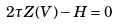<formula> <loc_0><loc_0><loc_500><loc_500>2 \tau Z ( V ) - H = 0</formula> 